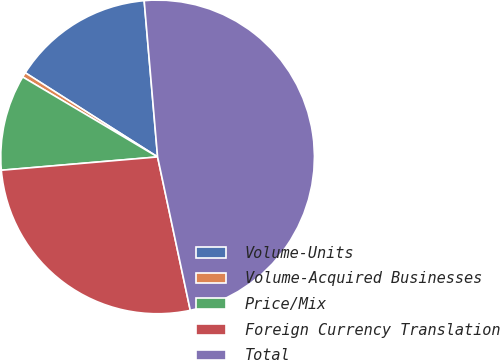Convert chart. <chart><loc_0><loc_0><loc_500><loc_500><pie_chart><fcel>Volume-Units<fcel>Volume-Acquired Businesses<fcel>Price/Mix<fcel>Foreign Currency Translation<fcel>Total<nl><fcel>14.62%<fcel>0.5%<fcel>9.87%<fcel>26.99%<fcel>48.02%<nl></chart> 